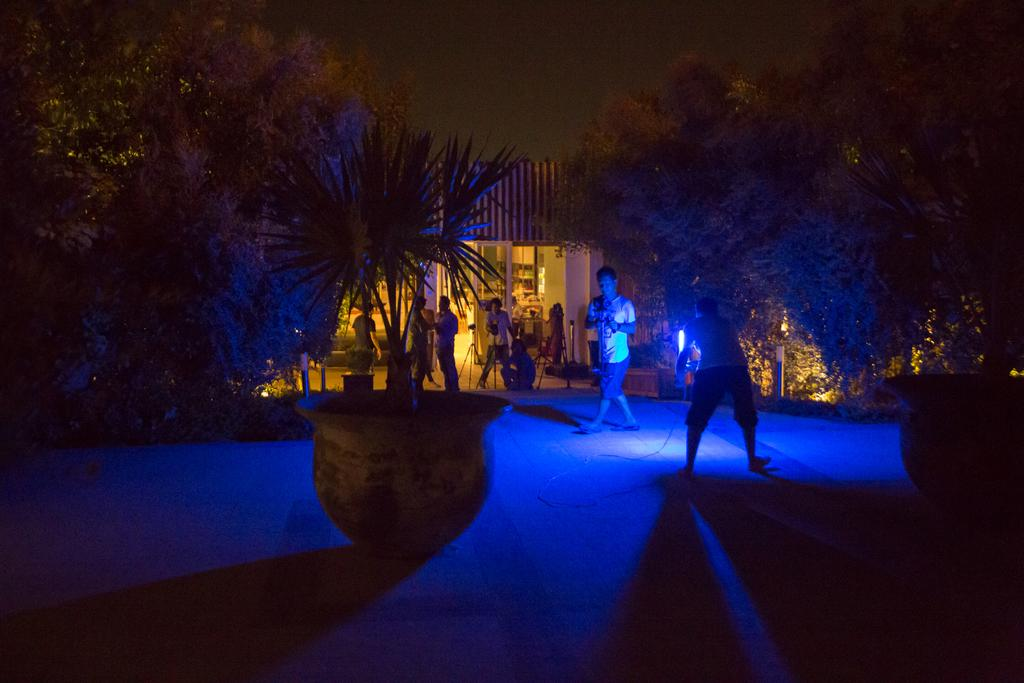Who or what can be seen in the image? There are people in the image. What type of objects are present with the people? There are plants with pots in the image. What other natural elements can be seen in the image? There are trees in the image. What type of structure is visible in the image? There is a house in the image. What might be used for displaying items or supporting objects in the image? There are stands in the image. What is visible in the background of the image? The sky is visible in the background of the image. Where is the jail located in the image? There is no jail present in the image. How does the impulse affect the balance of the plants in the image? There is no mention of an impulse or balance affecting the plants in the image; the plants are simply in pots. 